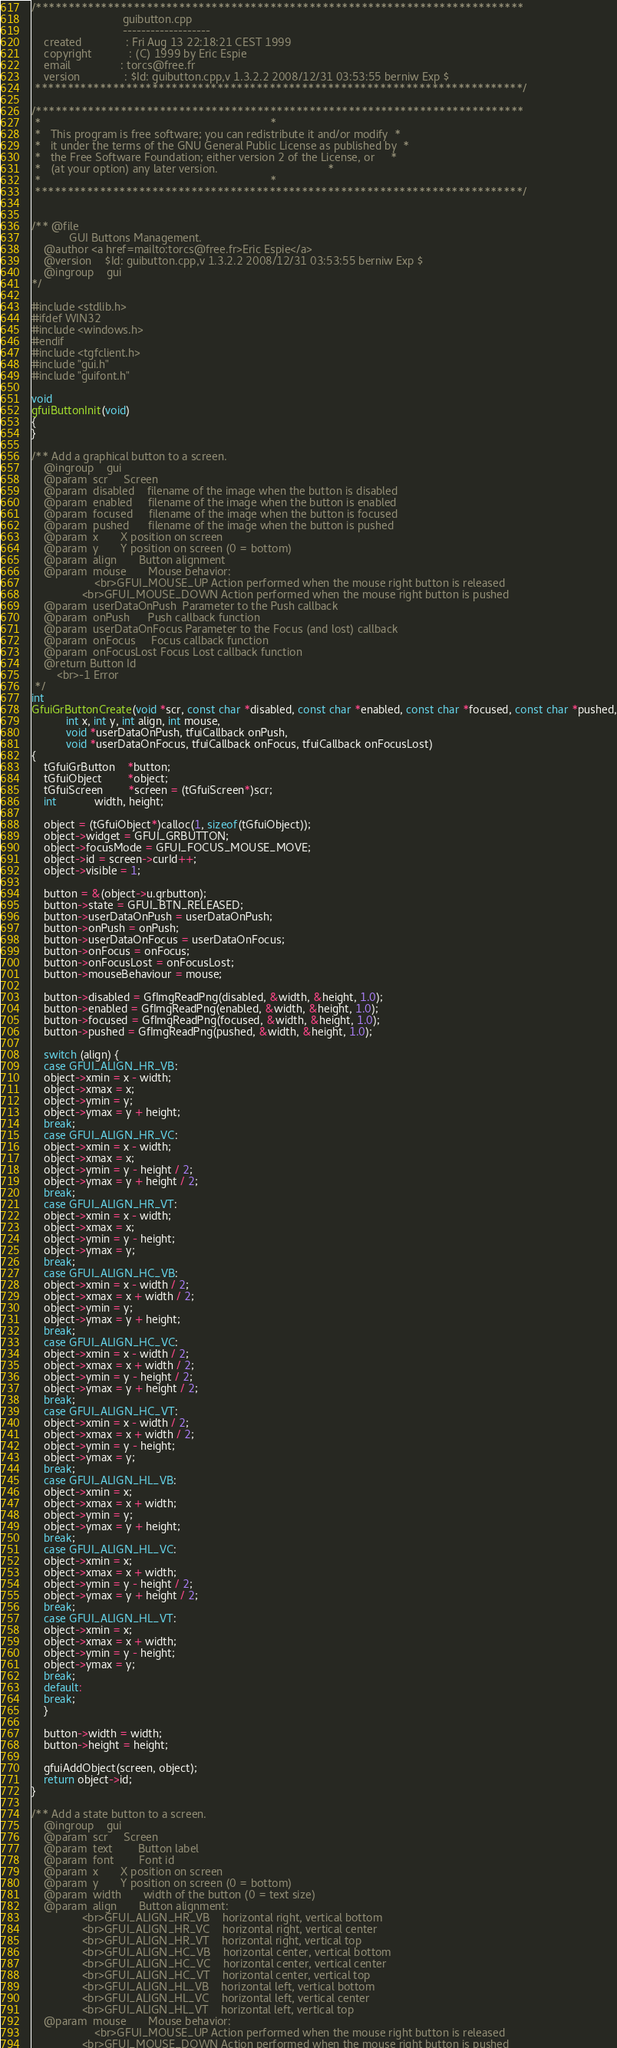<code> <loc_0><loc_0><loc_500><loc_500><_C++_>/***************************************************************************
                             guibutton.cpp                             
                             -------------------                                         
    created              : Fri Aug 13 22:18:21 CEST 1999
    copyright            : (C) 1999 by Eric Espie                         
    email                : torcs@free.fr   
    version              : $Id: guibutton.cpp,v 1.3.2.2 2008/12/31 03:53:55 berniw Exp $                                  
 ***************************************************************************/

/***************************************************************************
 *                                                                         *
 *   This program is free software; you can redistribute it and/or modify  *
 *   it under the terms of the GNU General Public License as published by  *
 *   the Free Software Foundation; either version 2 of the License, or     *
 *   (at your option) any later version.                                   *
 *                                                                         *
 ***************************************************************************/


/** @file   
    		GUI Buttons Management.
    @author	<a href=mailto:torcs@free.fr>Eric Espie</a>
    @version	$Id: guibutton.cpp,v 1.3.2.2 2008/12/31 03:53:55 berniw Exp $
    @ingroup	gui
*/

#include <stdlib.h>
#ifdef WIN32
#include <windows.h>
#endif
#include <tgfclient.h>
#include "gui.h"
#include "guifont.h"

void
gfuiButtonInit(void)
{
}

/** Add a graphical button to a screen.
    @ingroup	gui
    @param	scr		Screen
    @param	disabled	filename of the image when the button is disabled
    @param	enabled		filename of the image when the button is enabled
    @param	focused		filename of the image when the button is focused
    @param	pushed		filename of the image when the button is pushed
    @param	x		X position on screen
    @param	y		Y position on screen (0 = bottom)
    @param	align		Button alignment
    @param	mouse		Mouse behavior:
    				<br>GFUI_MOUSE_UP Action performed when the mouse right button is released
				<br>GFUI_MOUSE_DOWN Action performed when the mouse right button is pushed
    @param	userDataOnPush	Parameter to the Push callback
    @param	onPush		Push callback function
    @param	userDataOnFocus	Parameter to the Focus (and lost) callback
    @param	onFocus		Focus callback function
    @param	onFocusLost	Focus Lost callback function
    @return	Button Id
		<br>-1 Error
 */
int
GfuiGrButtonCreate(void *scr, const char *disabled, const char *enabled, const char *focused, const char *pushed,
		   int x, int y, int align, int mouse,
		   void *userDataOnPush, tfuiCallback onPush, 
		   void *userDataOnFocus, tfuiCallback onFocus, tfuiCallback onFocusLost)
{
    tGfuiGrButton	*button;
    tGfuiObject		*object;
    tGfuiScreen		*screen = (tGfuiScreen*)scr;
    int			width, height;
    
    object = (tGfuiObject*)calloc(1, sizeof(tGfuiObject));
    object->widget = GFUI_GRBUTTON;
    object->focusMode = GFUI_FOCUS_MOUSE_MOVE;
    object->id = screen->curId++;
    object->visible = 1;
    
    button = &(object->u.grbutton);
    button->state = GFUI_BTN_RELEASED;
    button->userDataOnPush = userDataOnPush;
    button->onPush = onPush;
    button->userDataOnFocus = userDataOnFocus;
    button->onFocus = onFocus;
    button->onFocusLost = onFocusLost;
    button->mouseBehaviour = mouse;

    button->disabled = GfImgReadPng(disabled, &width, &height, 1.0);
    button->enabled = GfImgReadPng(enabled, &width, &height, 1.0);
    button->focused = GfImgReadPng(focused, &width, &height, 1.0);
    button->pushed = GfImgReadPng(pushed, &width, &height, 1.0);

    switch (align) {
    case GFUI_ALIGN_HR_VB:
	object->xmin = x - width;
	object->xmax = x;
	object->ymin = y;
	object->ymax = y + height;
	break;
    case GFUI_ALIGN_HR_VC:
	object->xmin = x - width;
	object->xmax = x;
	object->ymin = y - height / 2;
	object->ymax = y + height / 2;
	break;
    case GFUI_ALIGN_HR_VT:
	object->xmin = x - width;
	object->xmax = x;
	object->ymin = y - height;
	object->ymax = y;
	break;
    case GFUI_ALIGN_HC_VB:
	object->xmin = x - width / 2;
	object->xmax = x + width / 2;
	object->ymin = y;
	object->ymax = y + height;
	break;
    case GFUI_ALIGN_HC_VC:
	object->xmin = x - width / 2;
	object->xmax = x + width / 2;
	object->ymin = y - height / 2;
	object->ymax = y + height / 2;
	break;
    case GFUI_ALIGN_HC_VT:
	object->xmin = x - width / 2;
	object->xmax = x + width / 2;
	object->ymin = y - height;
	object->ymax = y;
	break;
    case GFUI_ALIGN_HL_VB:
	object->xmin = x;
	object->xmax = x + width;
	object->ymin = y;
	object->ymax = y + height;
	break;
    case GFUI_ALIGN_HL_VC:
	object->xmin = x;
	object->xmax = x + width;
	object->ymin = y - height / 2;
	object->ymax = y + height / 2;
	break;
    case GFUI_ALIGN_HL_VT:
	object->xmin = x;
	object->xmax = x + width;
	object->ymin = y - height;
	object->ymax = y;
	break;
    default:
	break;
    }

    button->width = width;
    button->height = height;

    gfuiAddObject(screen, object);
    return object->id;
}

/** Add a state button to a screen.
    @ingroup	gui
    @param	scr		Screen
    @param	text		Button label
    @param	font		Font id
    @param	x		X position on screen
    @param	y		Y position on screen (0 = bottom)
    @param	width		width of the button (0 = text size)
    @param	align		Button alignment:
    			<br>GFUI_ALIGN_HR_VB	horizontal right, vertical bottom
    			<br>GFUI_ALIGN_HR_VC	horizontal right, vertical center
    			<br>GFUI_ALIGN_HR_VT	horizontal right, vertical top
    			<br>GFUI_ALIGN_HC_VB	horizontal center, vertical bottom
    			<br>GFUI_ALIGN_HC_VC	horizontal center, vertical center
    			<br>GFUI_ALIGN_HC_VT	horizontal center, vertical top
    			<br>GFUI_ALIGN_HL_VB	horizontal left, vertical bottom
    			<br>GFUI_ALIGN_HL_VC	horizontal left, vertical center
    			<br>GFUI_ALIGN_HL_VT	horizontal left, vertical top
    @param	mouse		Mouse behavior:
    				<br>GFUI_MOUSE_UP Action performed when the mouse right button is released
				<br>GFUI_MOUSE_DOWN Action performed when the mouse right button is pushed</code> 